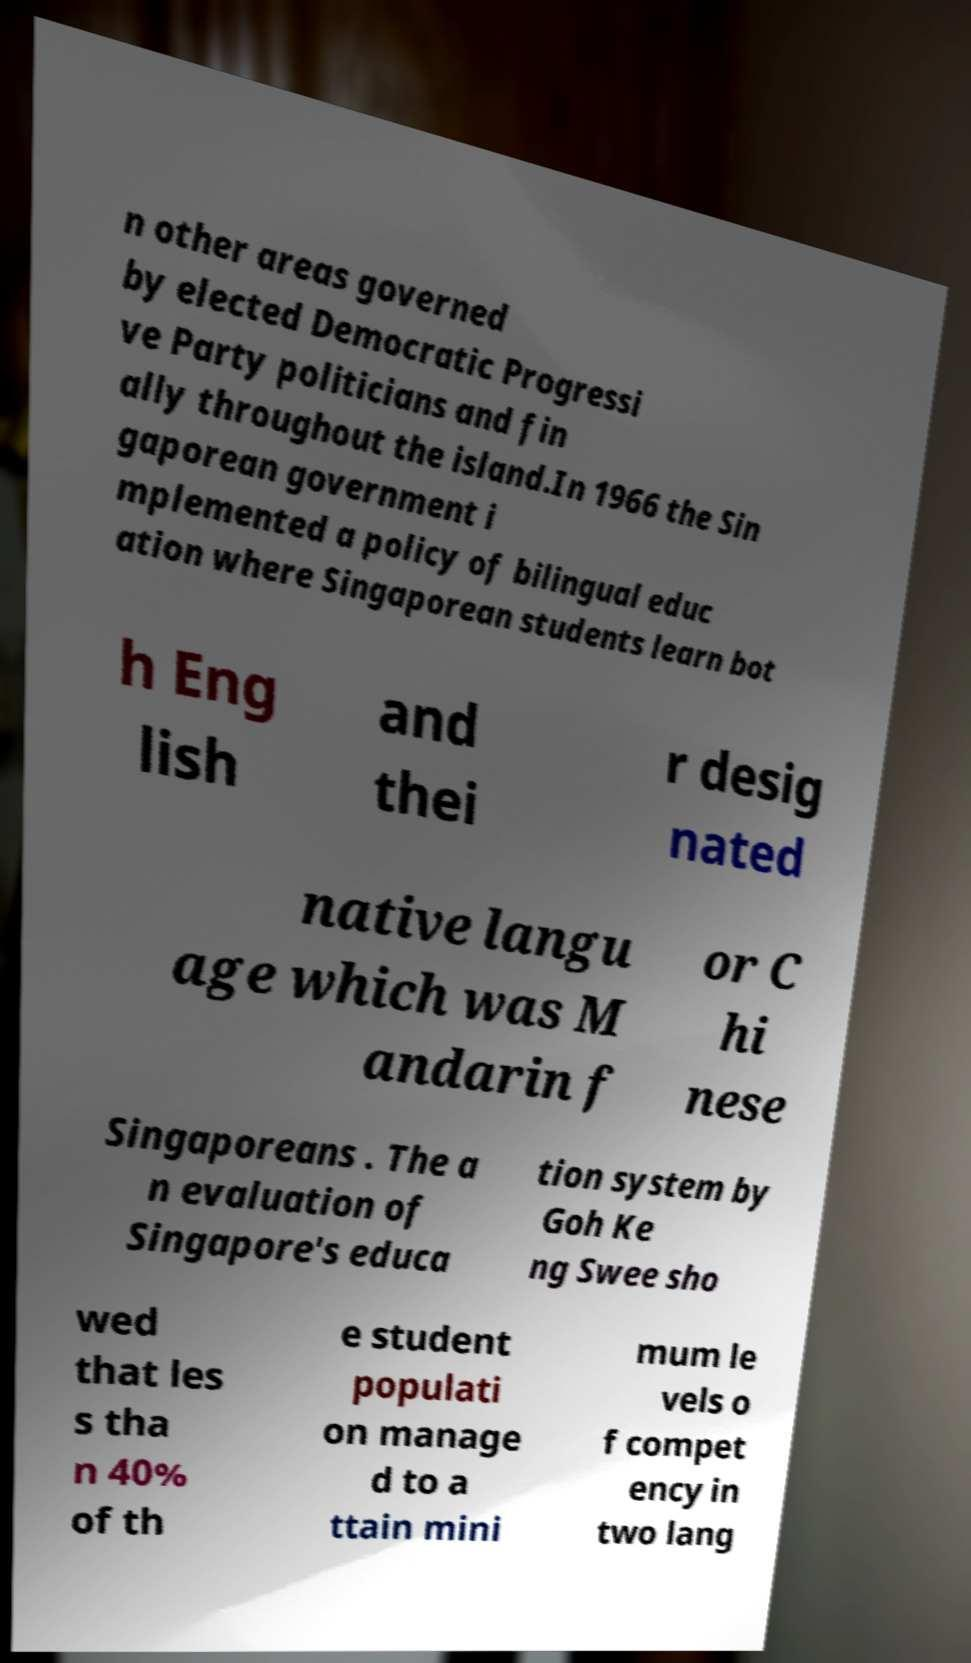Could you extract and type out the text from this image? n other areas governed by elected Democratic Progressi ve Party politicians and fin ally throughout the island.In 1966 the Sin gaporean government i mplemented a policy of bilingual educ ation where Singaporean students learn bot h Eng lish and thei r desig nated native langu age which was M andarin f or C hi nese Singaporeans . The a n evaluation of Singapore's educa tion system by Goh Ke ng Swee sho wed that les s tha n 40% of th e student populati on manage d to a ttain mini mum le vels o f compet ency in two lang 